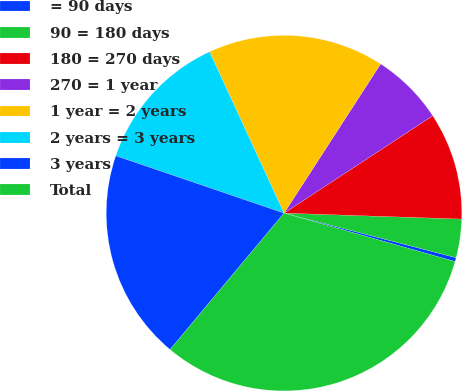<chart> <loc_0><loc_0><loc_500><loc_500><pie_chart><fcel>= 90 days<fcel>90 = 180 days<fcel>180 = 270 days<fcel>270 = 1 year<fcel>1 year = 2 years<fcel>2 years = 3 years<fcel>3 years<fcel>Total<nl><fcel>0.36%<fcel>3.5%<fcel>9.76%<fcel>6.63%<fcel>16.02%<fcel>12.89%<fcel>19.15%<fcel>31.68%<nl></chart> 